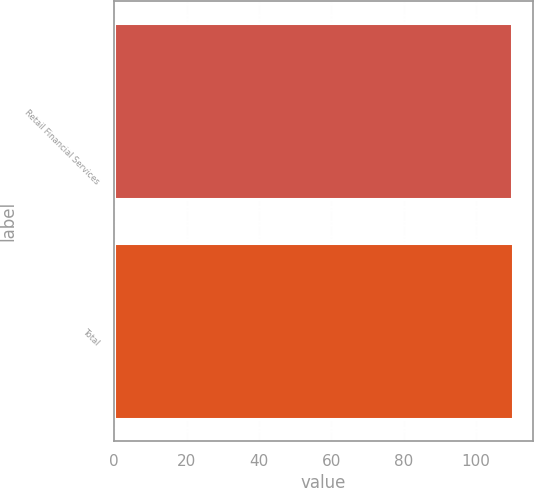<chart> <loc_0><loc_0><loc_500><loc_500><bar_chart><fcel>Retail Financial Services<fcel>Total<nl><fcel>110<fcel>110.1<nl></chart> 